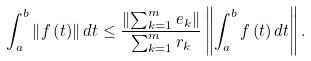<formula> <loc_0><loc_0><loc_500><loc_500>\int _ { a } ^ { b } \left \| f \left ( t \right ) \right \| d t \leq \frac { \left \| \sum _ { k = 1 } ^ { m } e _ { k } \right \| } { \sum _ { k = 1 } ^ { m } r _ { k } } \left \| \int _ { a } ^ { b } f \left ( t \right ) d t \right \| .</formula> 